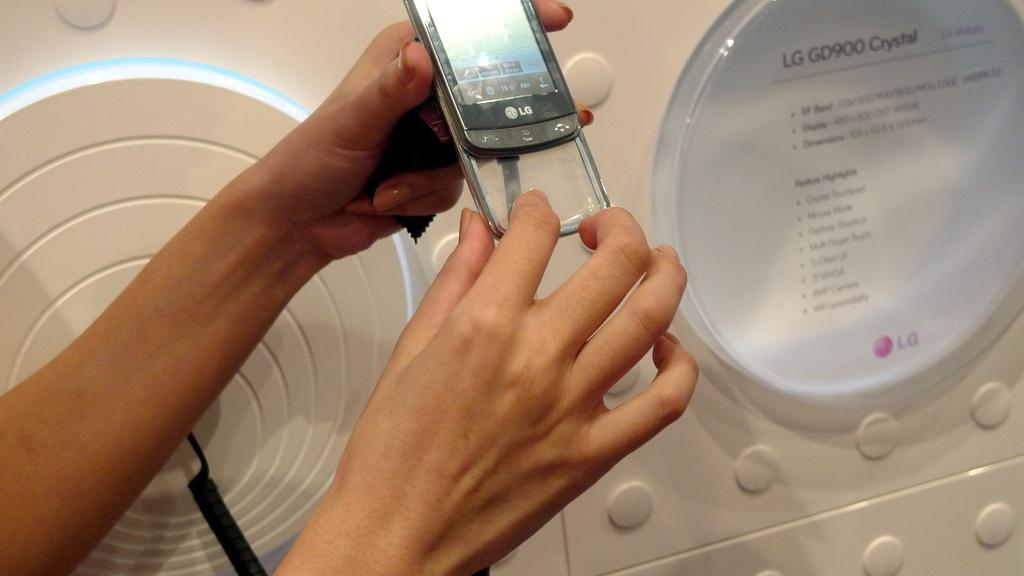<image>
Render a clear and concise summary of the photo. LG GD900 Crystal type smartphone case that slides on and off on the smartphone. 